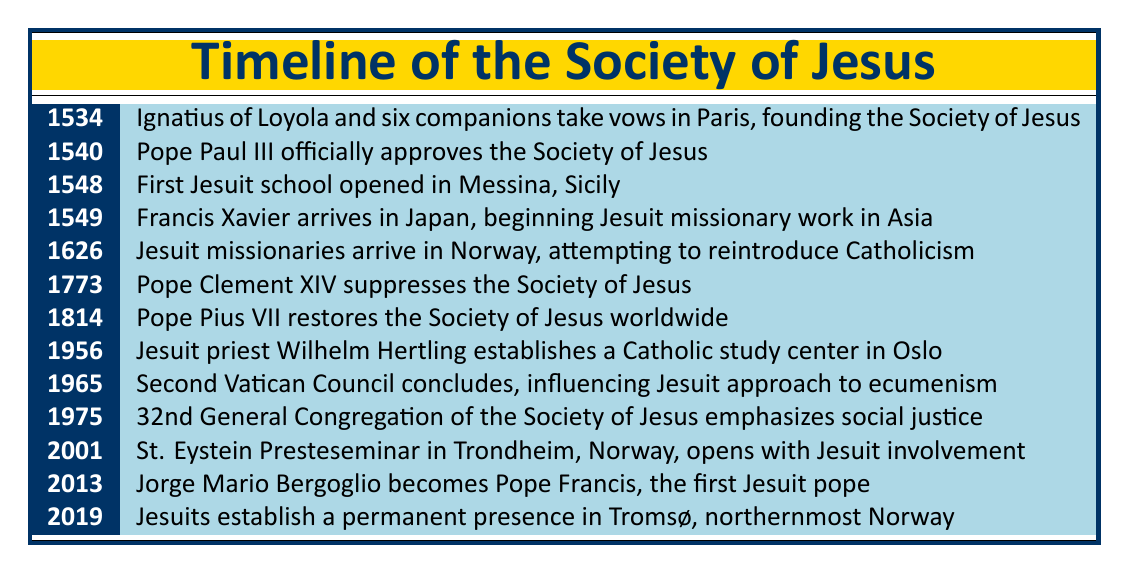What year was the Society of Jesus officially approved by Pope Paul III? The table lists the official approval of the Society of Jesus by Pope Paul III in the year 1540.
Answer: 1540 In what year did Jesuit missionaries arrive in Norway? According to the table, Jesuit missionaries arrived in Norway in the year 1626.
Answer: 1626 Was the first Jesuit school opened before or after Francis Xavier arrived in Japan? The first Jesuit school opened in 1548, and Francis Xavier arrived in Japan in 1549. So, the school opened before Xavier's arrival.
Answer: Before How many years did it take from the founding of the Society of Jesus to its suppression by Pope Clement XIV? The Society of Jesus was founded in 1534 and suppressed in 1773. To find the years between these events, subtract 1534 from 1773, which is 239 years.
Answer: 239 years Did the Society of Jesus exist continuously from its founding until its suppression? The table shows that the Society was suppressed in 1773 and was later restored in 1814. Therefore, it did not exist continuously between its founding and restoration.
Answer: No What was a significant action taken by Pope Pius VII regarding the Society of Jesus? The table states that Pope Pius VII restored the Society of Jesus worldwide in 1814. This indicates a significant action of restoration after suppression.
Answer: Restored the Society of Jesus Calculate the number of years from the establishment of a Catholic study center in Oslo to the conclusion of the Second Vatican Council. The Catholic study center was established in 1956, and the Second Vatican Council concluded in 1965. To find the difference, subtract 1956 from 1965, which equals 9 years.
Answer: 9 years In which year did Jorge Mario Bergoglio become Pope Francis, the first Jesuit pope? The table indicates that Jorge Mario Bergoglio became Pope Francis in 2013, making this a significant event in the history of the Society.
Answer: 2013 How many key events in the history of the Society of Jesus listed occurred in the 20th century? By examining the table, there are four events: the establishment of a study center in Oslo (1956), conclusion of the Second Vatican Council (1965), emphasizing social justice in 1975, and Jesuit involvement in St. Eystein Presteseminar (2001), totaling four events.
Answer: 4 events 